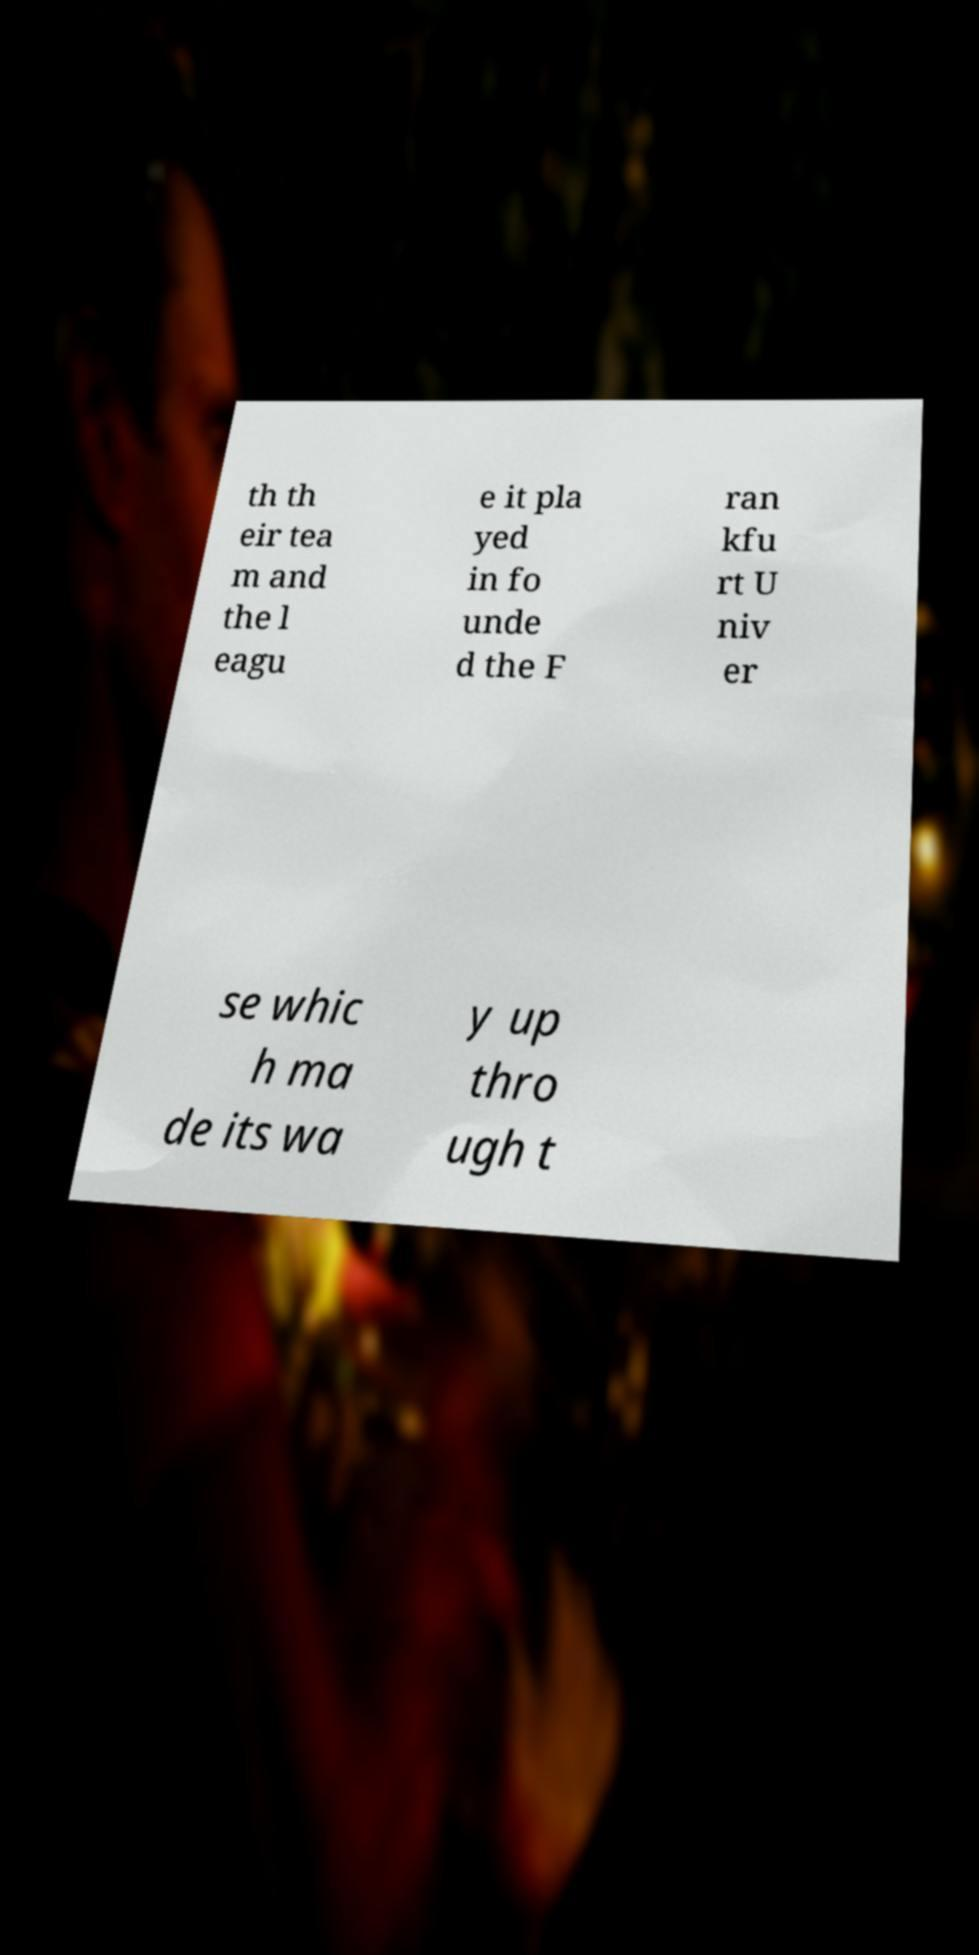What messages or text are displayed in this image? I need them in a readable, typed format. th th eir tea m and the l eagu e it pla yed in fo unde d the F ran kfu rt U niv er se whic h ma de its wa y up thro ugh t 